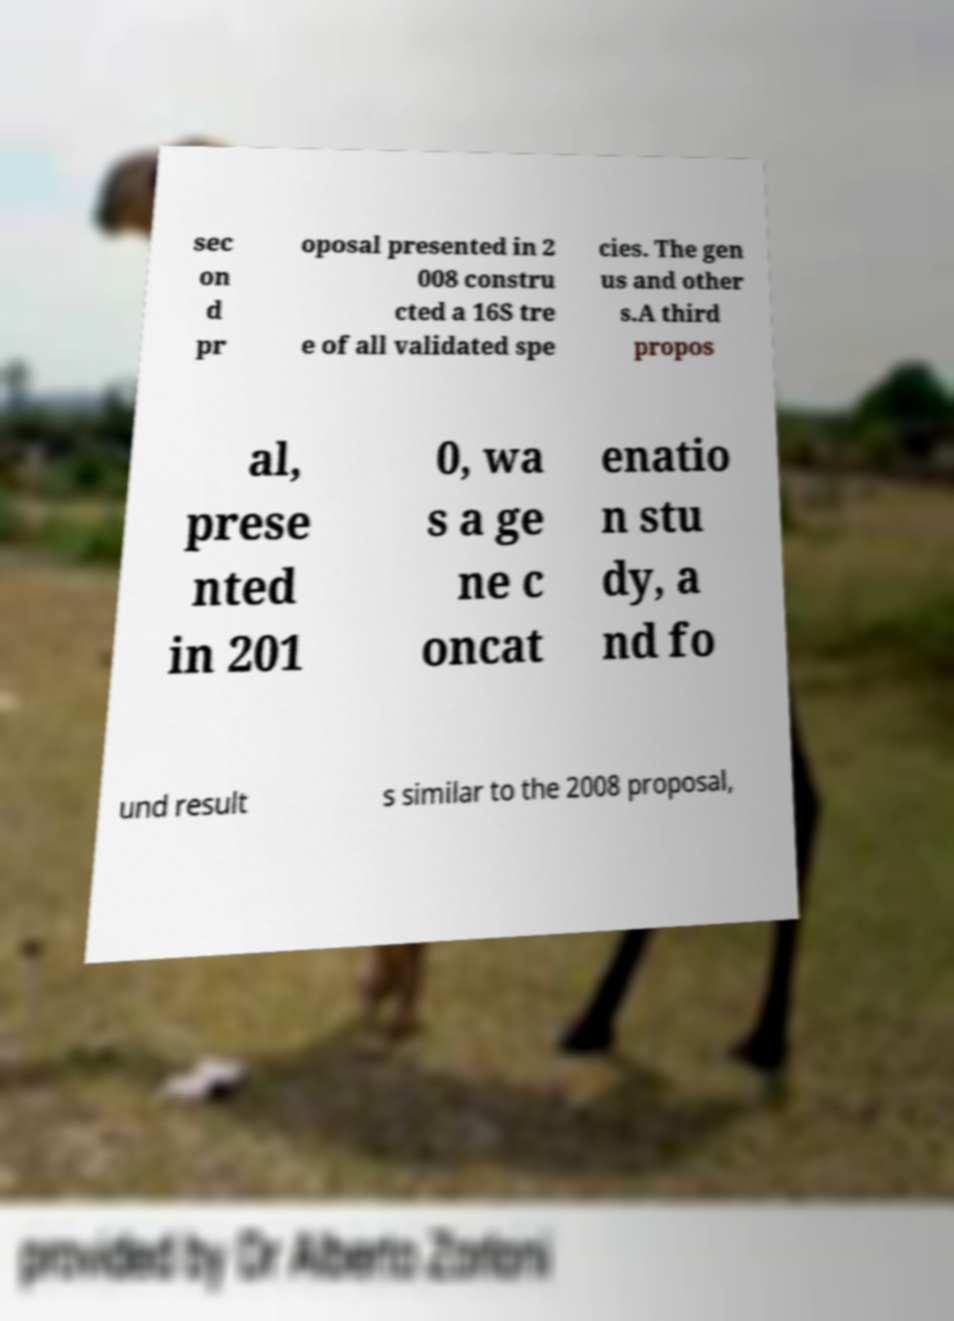Could you extract and type out the text from this image? sec on d pr oposal presented in 2 008 constru cted a 16S tre e of all validated spe cies. The gen us and other s.A third propos al, prese nted in 201 0, wa s a ge ne c oncat enatio n stu dy, a nd fo und result s similar to the 2008 proposal, 